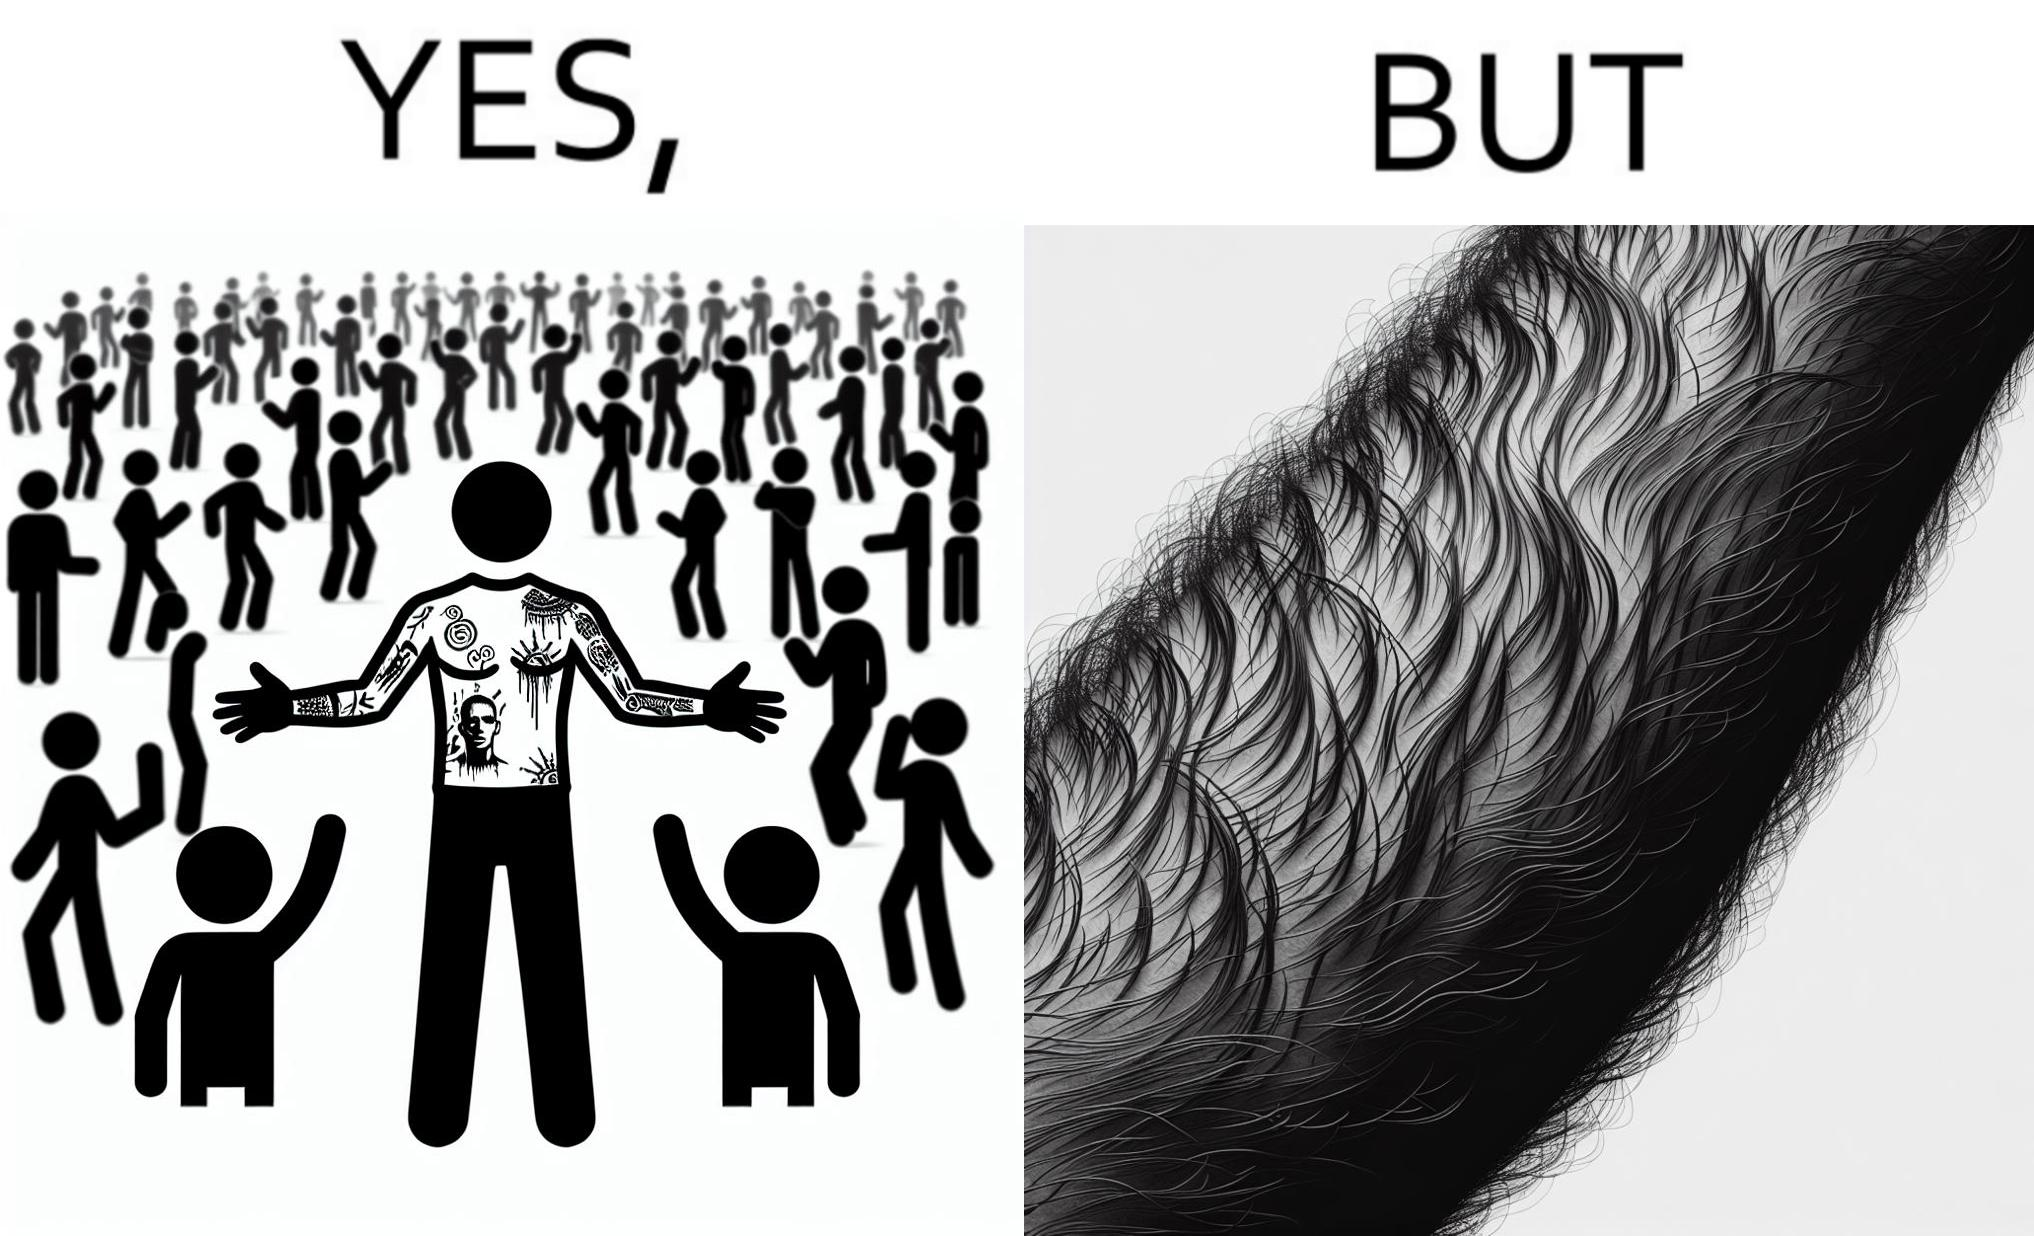Describe the content of this image. The image is funny because while from the distance it seems that the man has big tattoos on both of his arms upon a closer look at the arms it turns out there is no tattoo and what seemed to be tattoos are just hairs on his arm. 